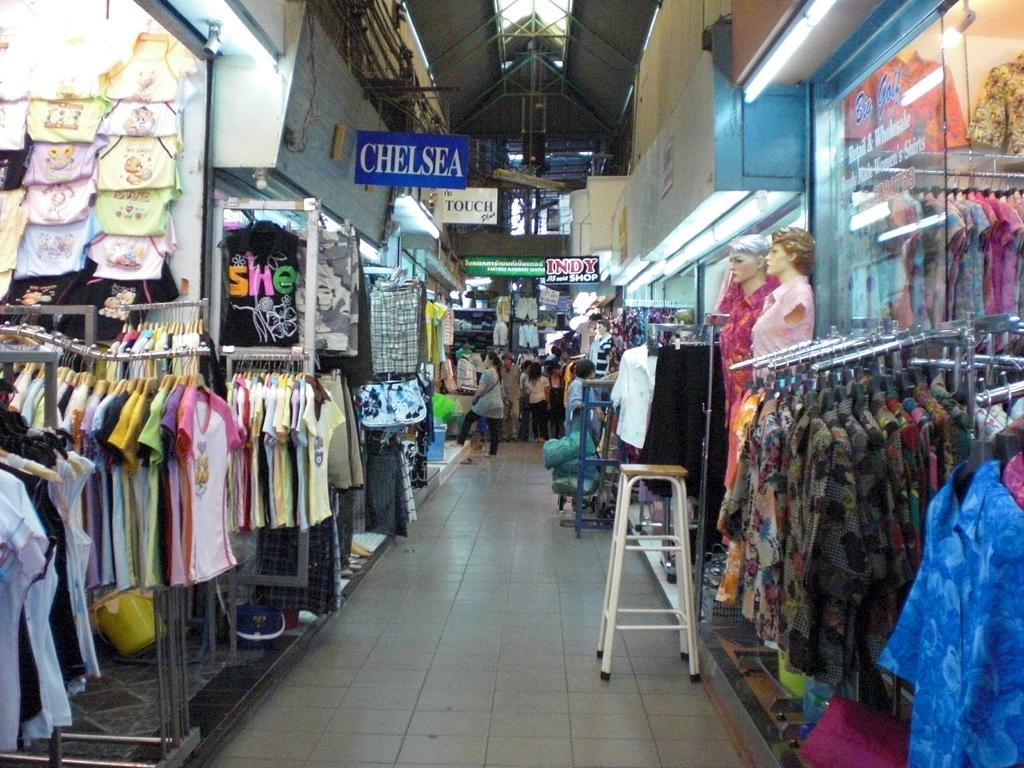<image>
Create a compact narrative representing the image presented. A long aisle of clothes with a Chelsea sign above them 